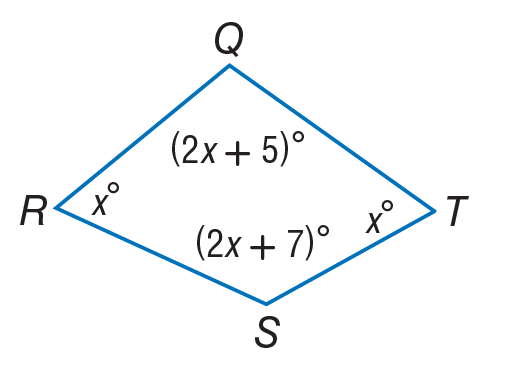Answer the mathemtical geometry problem and directly provide the correct option letter.
Question: Find m \angle Q.
Choices: A: 50 B: 58 C: 60 D: 121 D 